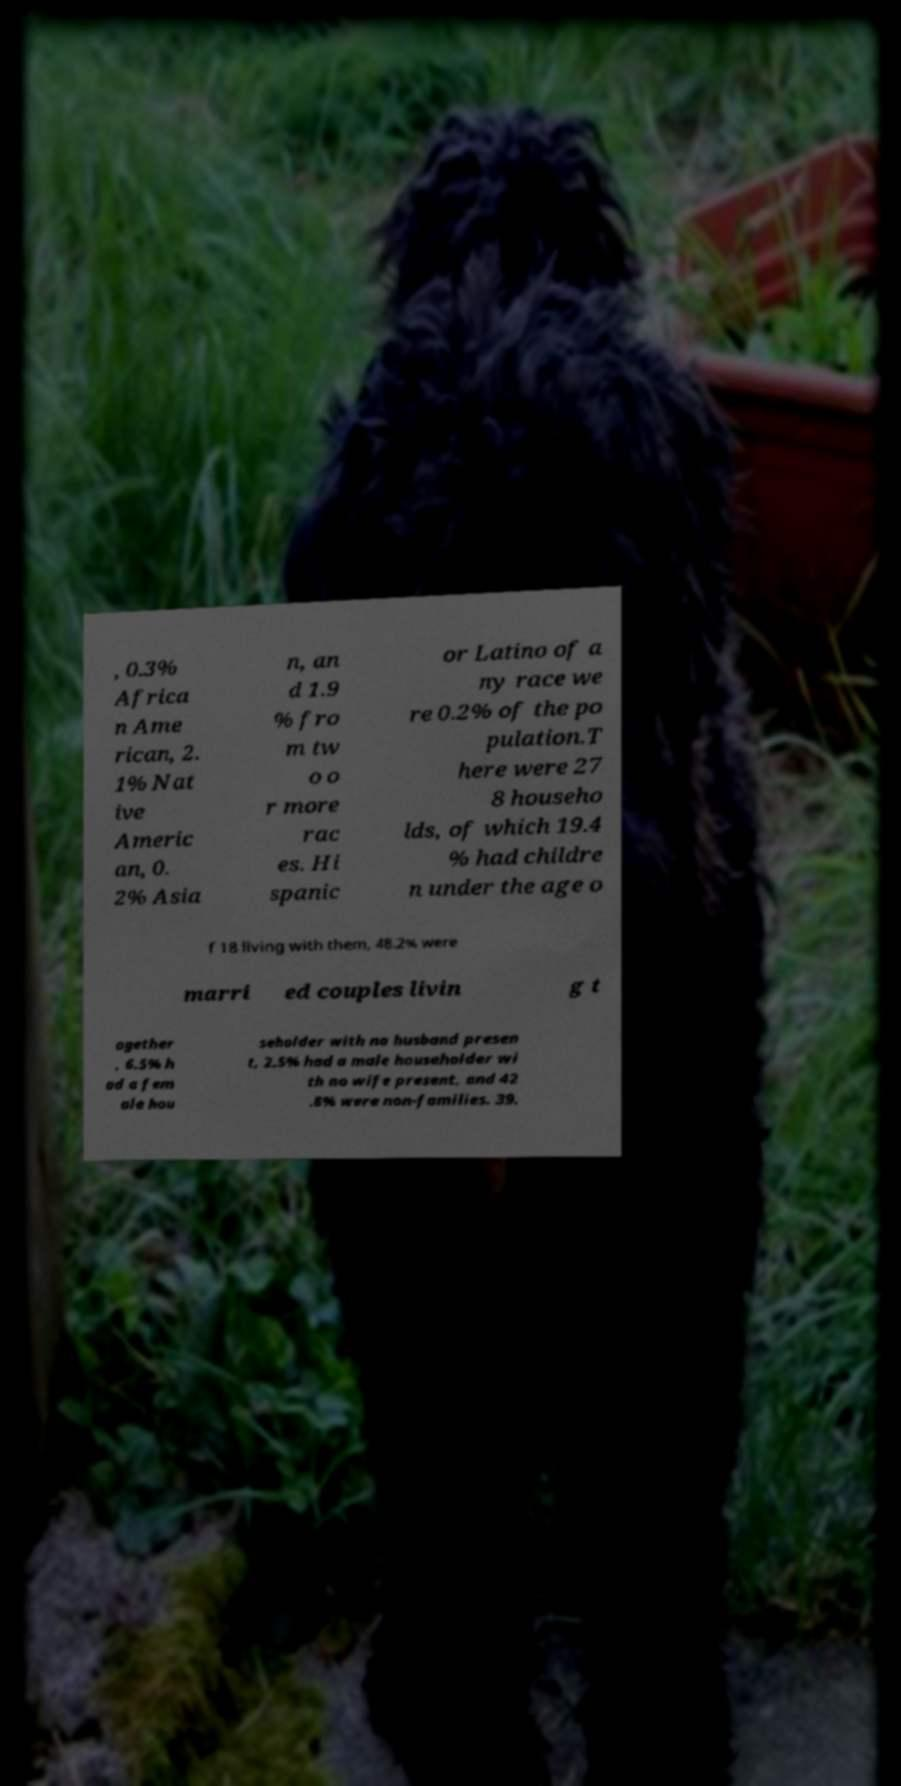I need the written content from this picture converted into text. Can you do that? , 0.3% Africa n Ame rican, 2. 1% Nat ive Americ an, 0. 2% Asia n, an d 1.9 % fro m tw o o r more rac es. Hi spanic or Latino of a ny race we re 0.2% of the po pulation.T here were 27 8 househo lds, of which 19.4 % had childre n under the age o f 18 living with them, 48.2% were marri ed couples livin g t ogether , 6.5% h ad a fem ale hou seholder with no husband presen t, 2.5% had a male householder wi th no wife present, and 42 .8% were non-families. 39. 